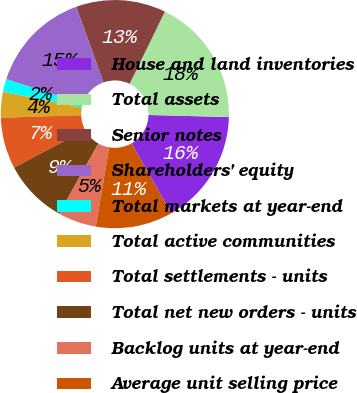Convert chart. <chart><loc_0><loc_0><loc_500><loc_500><pie_chart><fcel>House and land inventories<fcel>Total assets<fcel>Senior notes<fcel>Shareholders' equity<fcel>Total markets at year-end<fcel>Total active communities<fcel>Total settlements - units<fcel>Total net new orders - units<fcel>Backlog units at year-end<fcel>Average unit selling price<nl><fcel>16.36%<fcel>18.18%<fcel>12.73%<fcel>14.55%<fcel>1.82%<fcel>3.64%<fcel>7.27%<fcel>9.09%<fcel>5.45%<fcel>10.91%<nl></chart> 